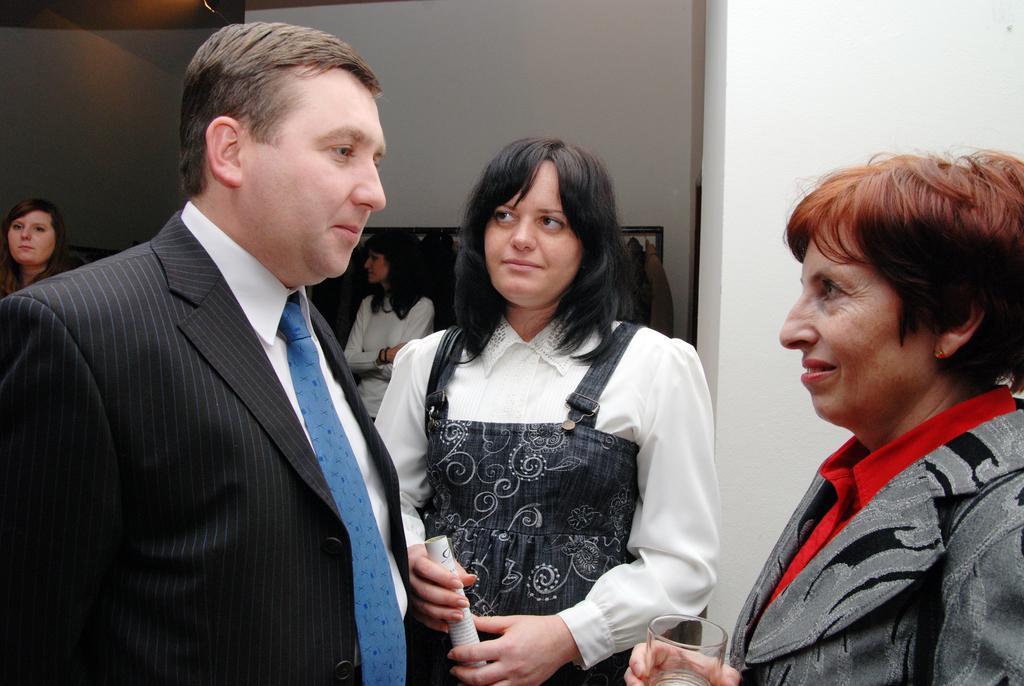How would you summarize this image in a sentence or two? Here we can see three persons. She is holding a paper with her hands and she is holding a glass. In the background we can see few persons and wall. 